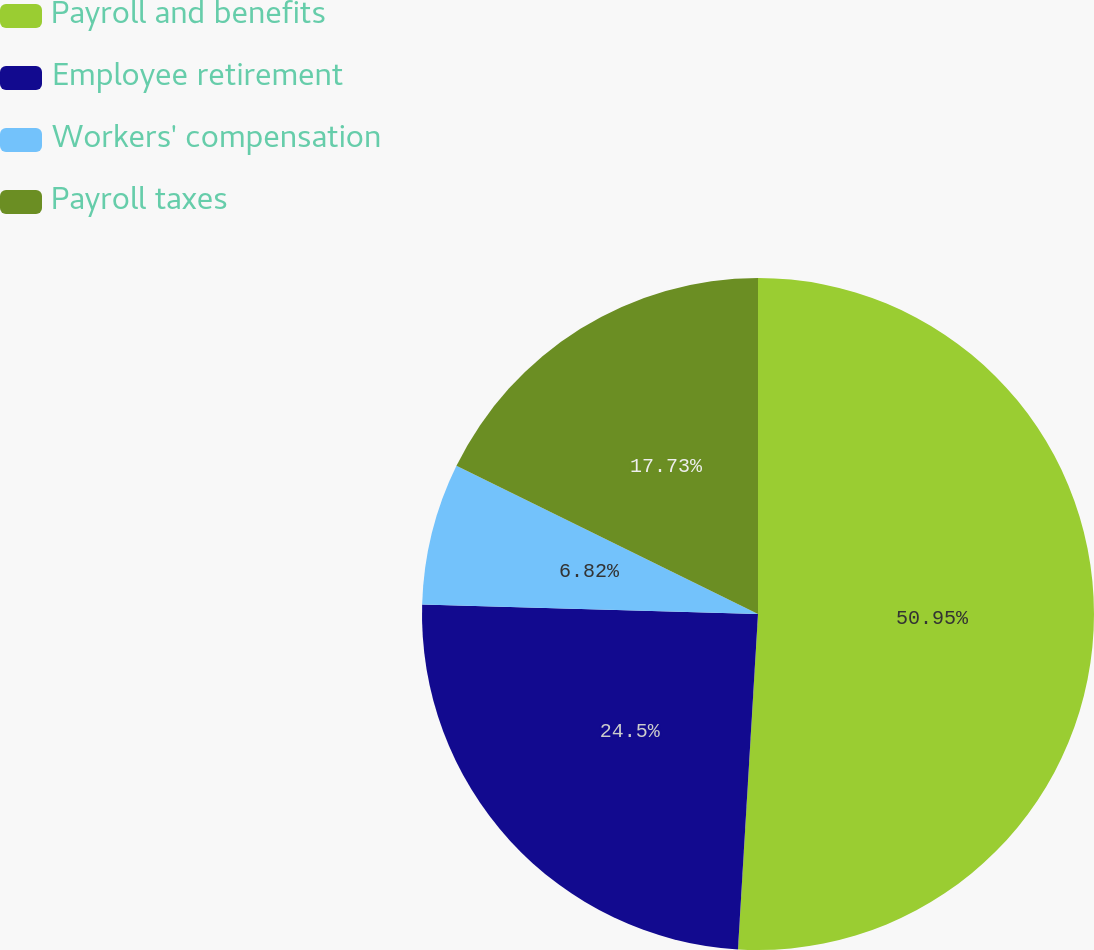Convert chart. <chart><loc_0><loc_0><loc_500><loc_500><pie_chart><fcel>Payroll and benefits<fcel>Employee retirement<fcel>Workers' compensation<fcel>Payroll taxes<nl><fcel>50.95%<fcel>24.5%<fcel>6.82%<fcel>17.73%<nl></chart> 